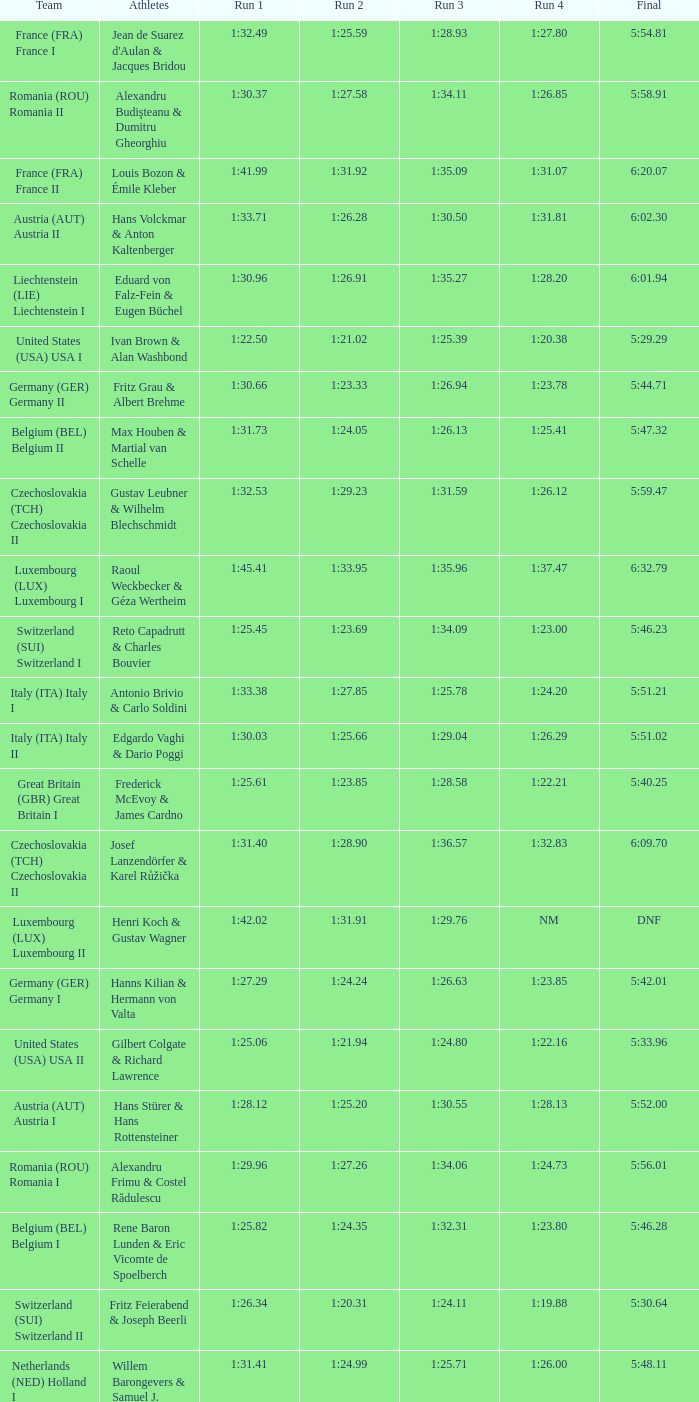Which Run 4 has Athletes of alexandru frimu & costel rădulescu? 1:24.73. 